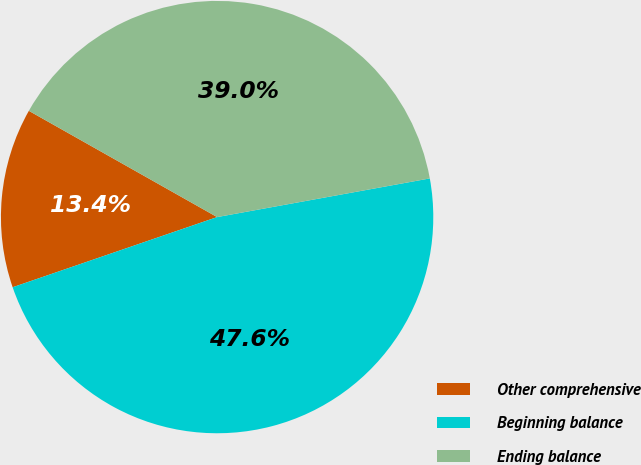<chart> <loc_0><loc_0><loc_500><loc_500><pie_chart><fcel>Other comprehensive<fcel>Beginning balance<fcel>Ending balance<nl><fcel>13.44%<fcel>47.6%<fcel>38.96%<nl></chart> 